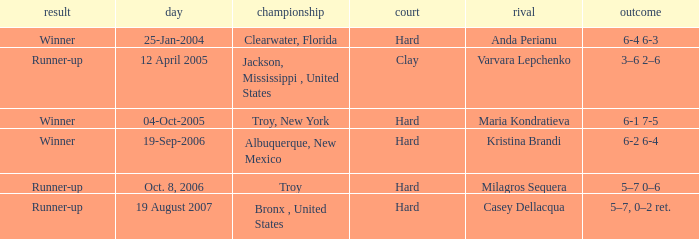What was the surface of the game that resulted in a final score of 6-1 7-5? Hard. 